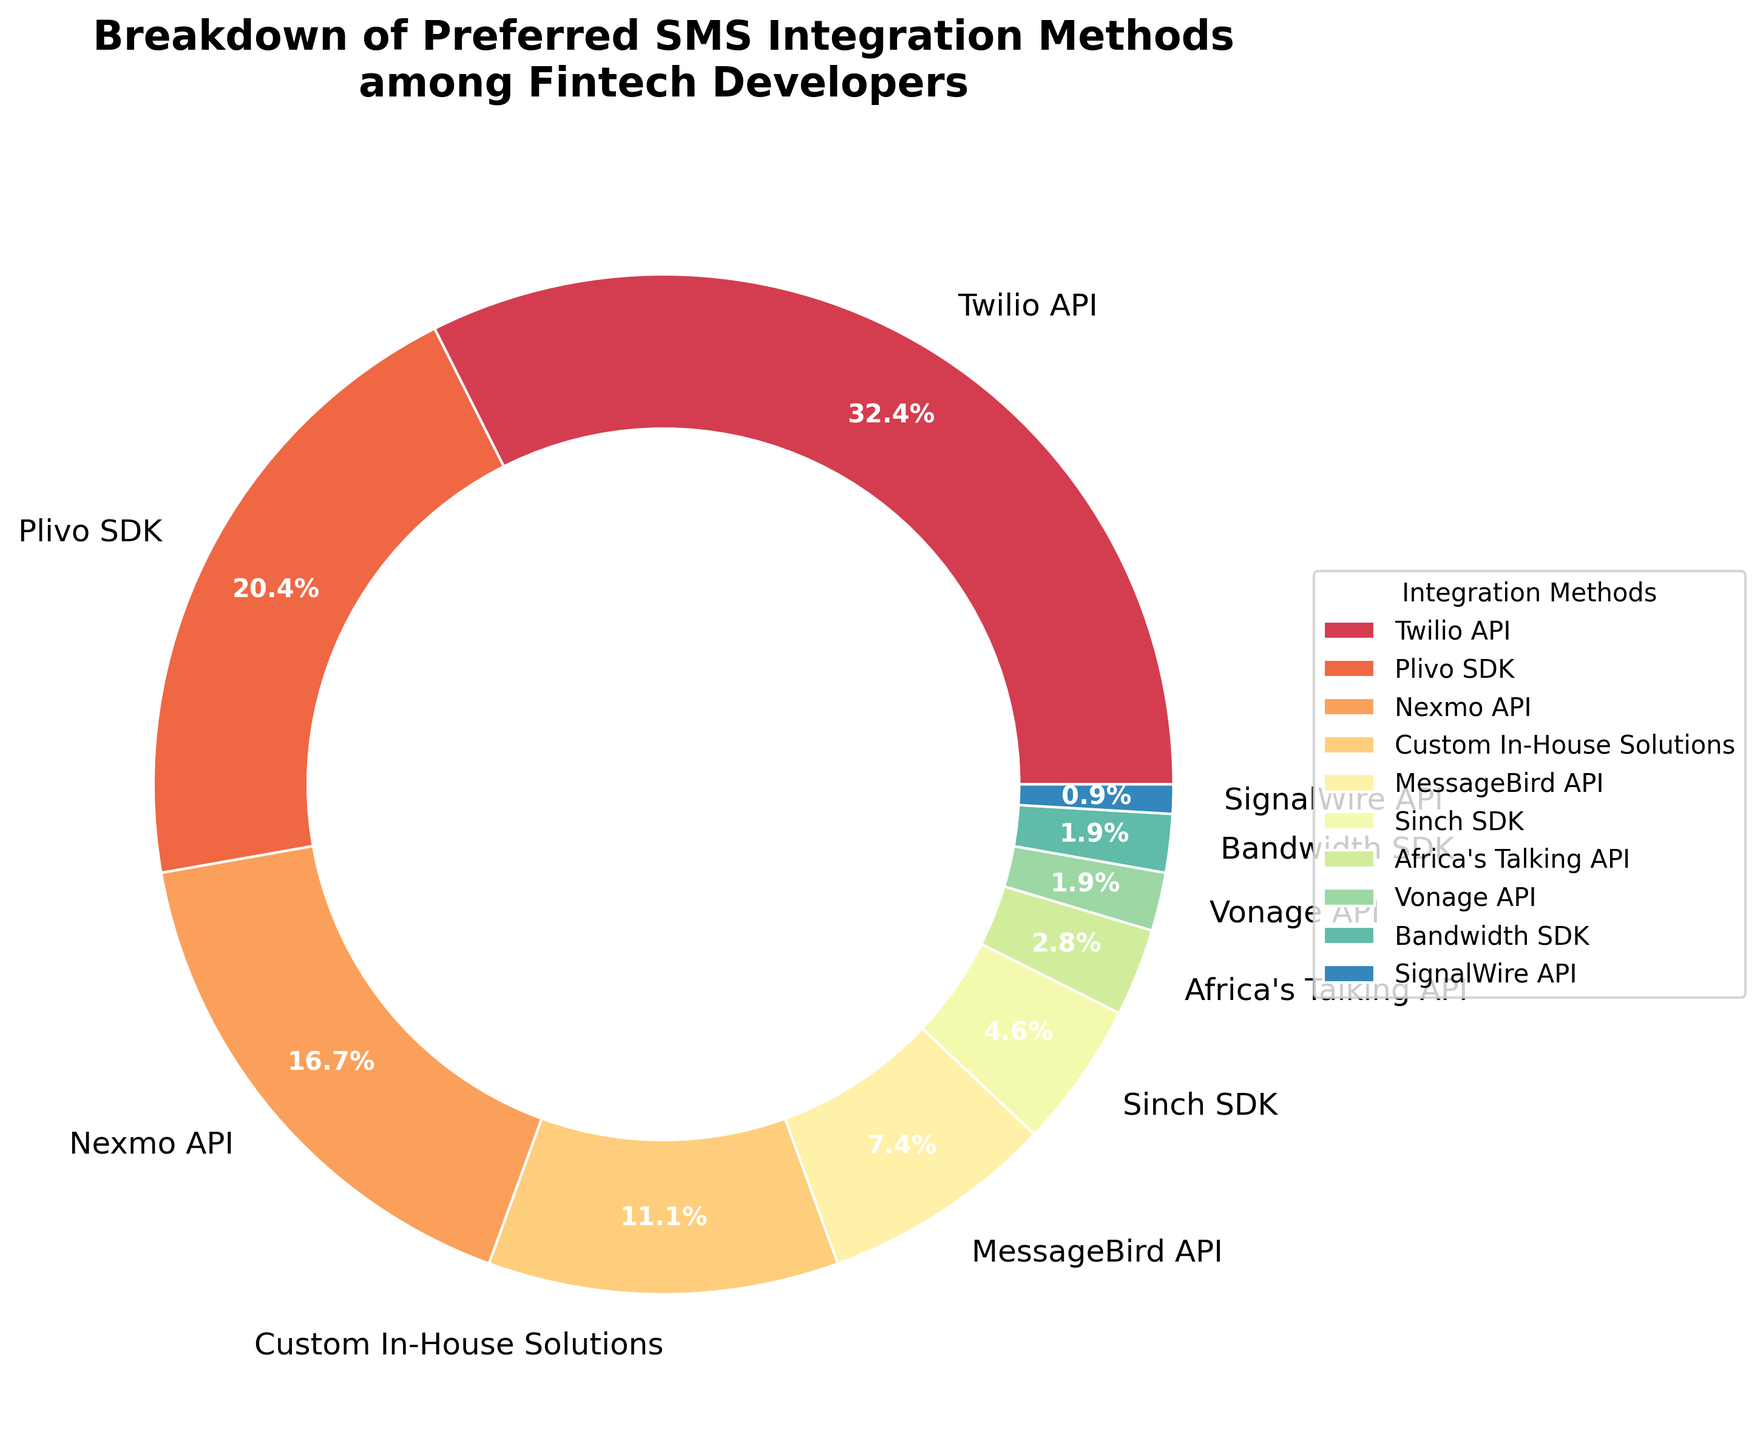What's the most preferred SMS integration method among fintech developers? The figure shows a pie chart with various SMS integration methods. The largest wedge represents the method with the highest percentage. The Twilio API has the largest wedge at 35%.
Answer: Twilio API How many percentage points more does the Plivo SDK have compared to the Nexmo API? From the figure, Plivo SDK has 22% and Nexmo API has 18%. The difference is 22% - 18% = 4%.
Answer: 4% Which methods collectively account for more than half of the preferred integration methods among fintech developers? Adding the percentages of each method starting from the largest until we surpass 50%. Twilio API is 35%, adding Plivo SDK’s 22% gives us 57%, surpassing half. So, Twilio API and Plivo SDK together account for more than half.
Answer: Twilio API, Plivo SDK What is the combined percentage of developers preferring Sinch SDK, Africa's Talking API, Vonage API, Bandwidth SDK, and SignalWire API? Adding the individual percentages: Sinch SDK (5%) + Africa's Talking API (3%) + Vonage API (2%) + Bandwidth SDK (2%) + SignalWire API (1%) = 13%.
Answer: 13% Is MessageBird API more preferred than Custom In-House Solutions? Comparing their respective wedges: Custom In-House Solutions (12%) and MessageBird API (8%). Since 12 is greater than 8, MessageBird API is less preferred.
Answer: No Which method is exactly half as popular compared to the Twilio API? The Twilio API accounts for 35%. Dividing this by 2 gives 17.5%, rounding that does not match any exact method, but Nexmo API at 18% is very close to half of 35%.
Answer: Nexmo API (approximately) What percentage of developers prefer an API-based solution over an SDK-based solution? Adding percentages of all API methods: Twilio (35%) + Nexmo (18%) + MessageBird (8%) + Africa's Talking (3%) + Vonage (2%) + SignalWire (1%) = 67%. SDK methods: Plivo (22%) + Sinch (5%) + Bandwidth (2%) = 29%.
Answer: 67% prefer API, 29% prefer SDK Which method has the smallest wedge in the pie chart? Locating the smallest wedge in the pie chart, we see that the SignalWire API, at 1%, is the smallest.
Answer: SignalWire API Are more developers using Custom In-House Solutions than using the combination of Africa's Talking API and Vonage API? Custom In-House Solutions is at 12%. Adding Africa's Talking API (3%) + Vonage API (2%) gives 5%. Since 12% is greater than 5%, more developers use Custom In-House Solutions.
Answer: Yes Which SDK method has the lowest percentage and what is it? Comparing the SDK methods: Plivo SDK (22%), Sinch SDK (5%), Bandwidth SDK (2%). The lowest is the Bandwidth SDK at 2%.
Answer: Bandwidth SDK, 2% 